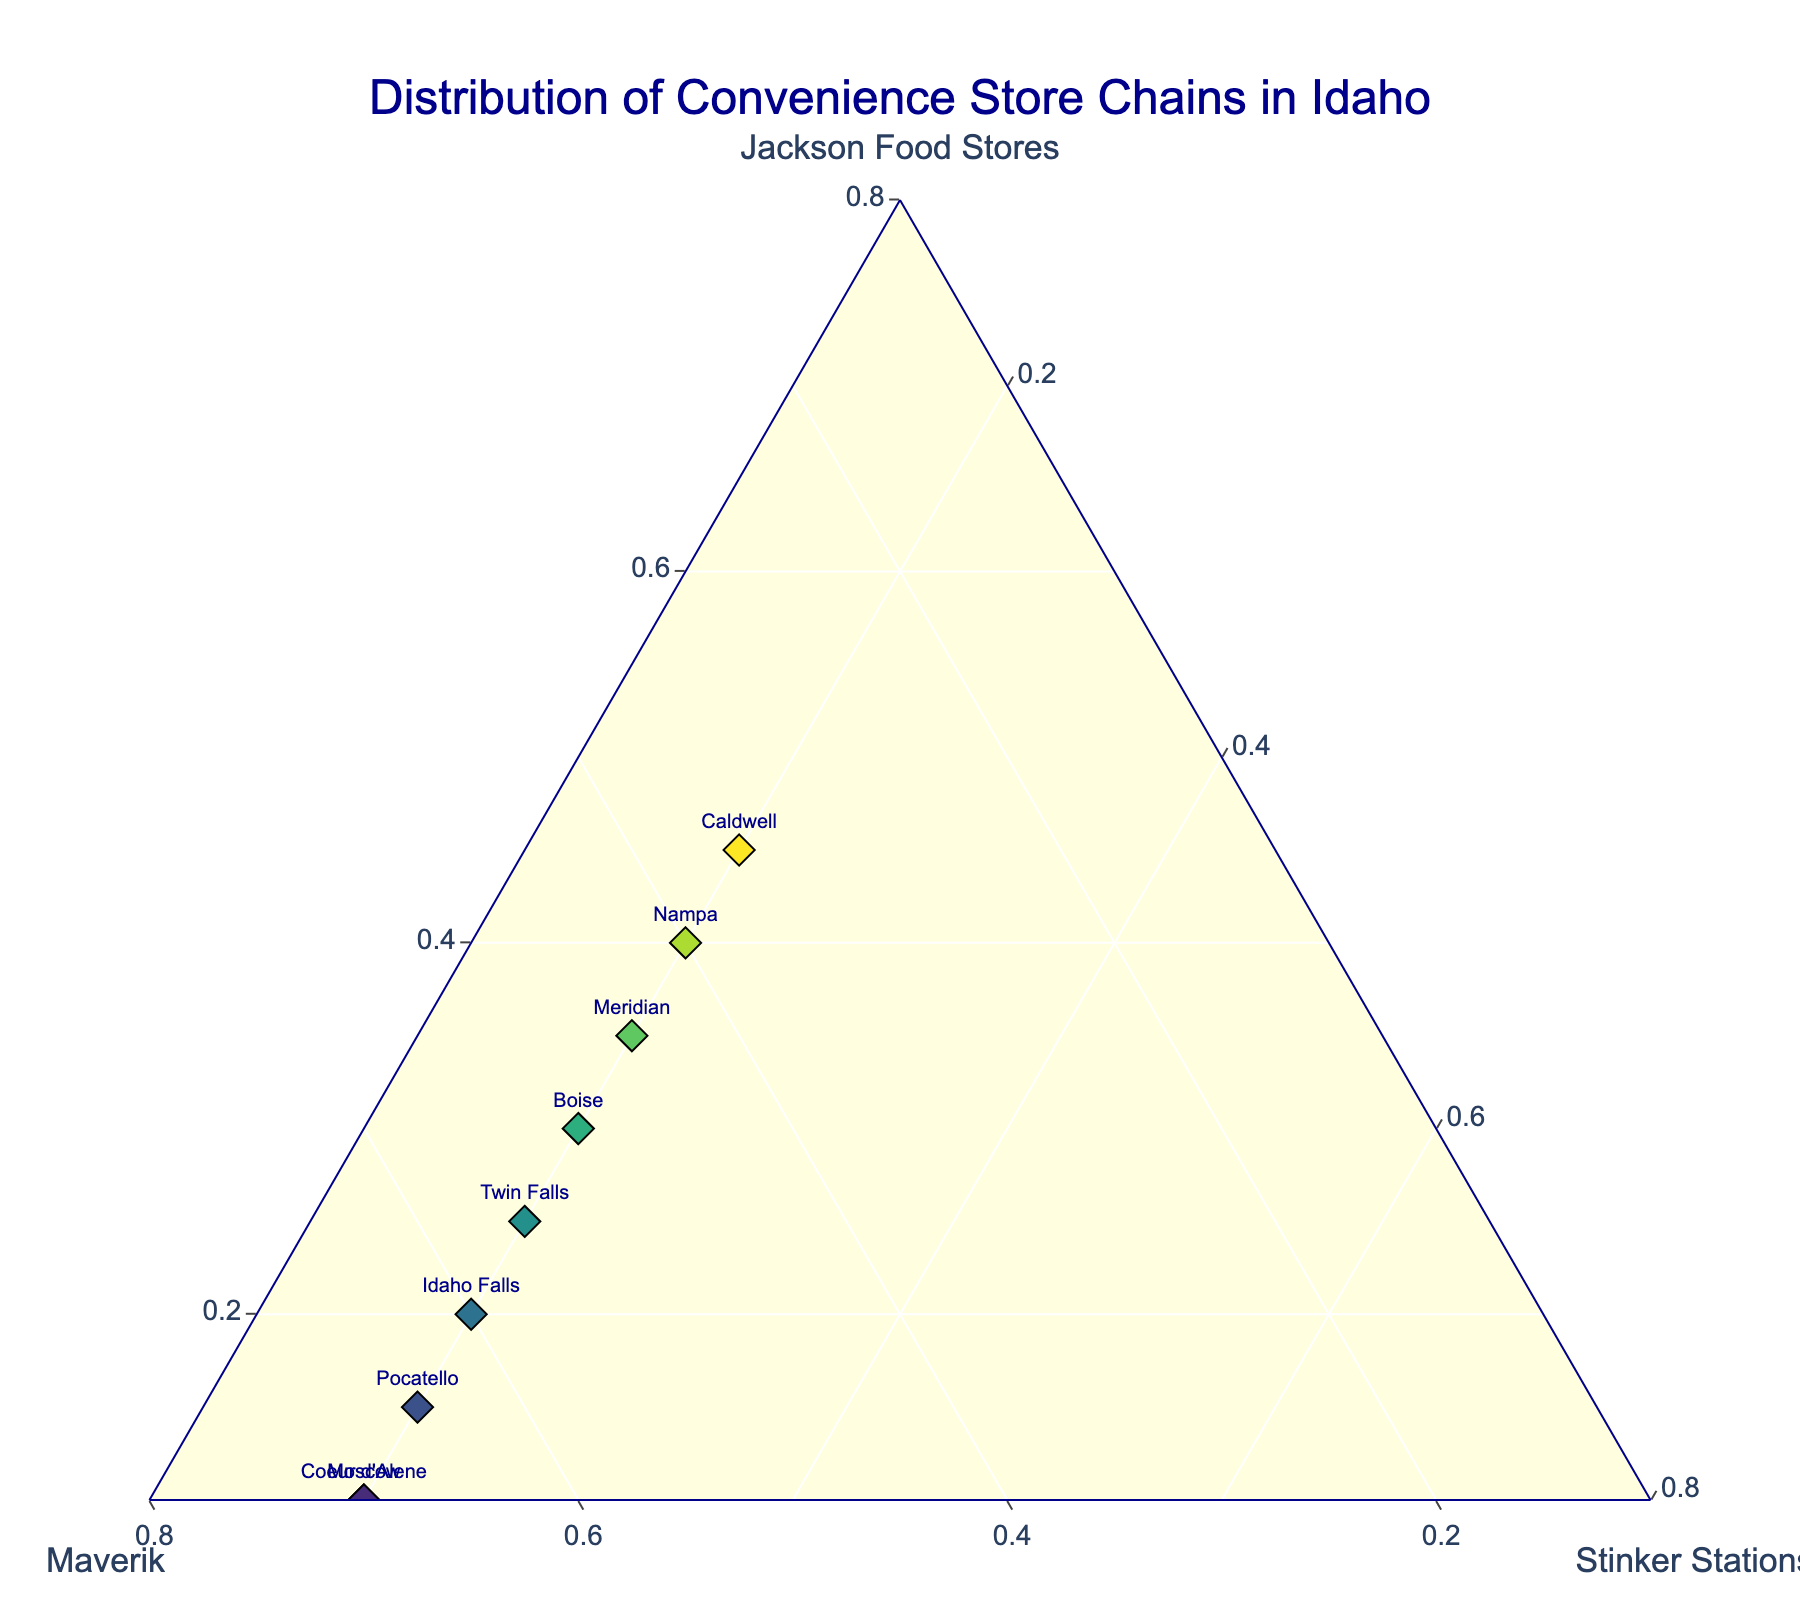What is the title of the figure? The title of the figure is displayed at the top center of the plot. By reading it, we can directly identify the title.
Answer: Distribution of Convenience Store Chains in Idaho What are the convenience store chains compared in the plot? The axes titles of the ternary plot indicate the three convenience store chains compared in the figure.
Answer: Jackson Food Stores, Maverik, Stinker Stations Which city has the highest proportion of Jackson Food Stores? By looking at the points positioned closest to the "Jackson Food Stores" axis, we can identify the city with the highest proportion.
Answer: Caldwell Which city has the highest proportion of Maverik? By examining the points positioned closest to the "Maverik" axis, we can determine the city with the highest proportion.
Answer: Lewiston How many locations have more than 50% representation from Maverik? Checking the positions of the points to see how many are closest to the "Maverik" axis and interpreting their positions based on the scale ticks greater than 0.5.
Answer: 5 locations In which city is the proportion of Jackson Food Stores equal to the proportion of Maverik? By finding the point(s) that are equidistant from the axes for Jackson Food Stores and Maverik and reading the corresponding city's label.
Answer: Nampa What is the smallest proportion of Jackson Food Stores and which city has it? Locate the point closest to the "Maverik" and "Stinker Stations" axes, indicating the least presence of Jackson Food Stores, and identify the city from the label.
Answer: Lewiston Among the cities of Boise and Meridian, which has a higher proportion of Maverik? Compare the vertical positions of the points for Boise and Meridian to determine which has a higher percentage of Maverik.
Answer: Boise In what ratio do Caldwell, Nampa, and Boise distribute their convenience store chains? (Provide the ratios for Jackson Food Stores, Maverik, and Stinker Stations respectively) Reference the exact values given for each city in the dataset to describe their distribution ratios accurately.
Answer: Caldwell: 0.45, 0.35, 0.20; Nampa: 0.40, 0.40, 0.20; Boise: 0.30, 0.50, 0.20 Which city has the most balanced representation of all three convenience store chains? Identify the point that appears most central within the ternary plot, implying near-equal representation among the three chains.
Answer: Nampa 